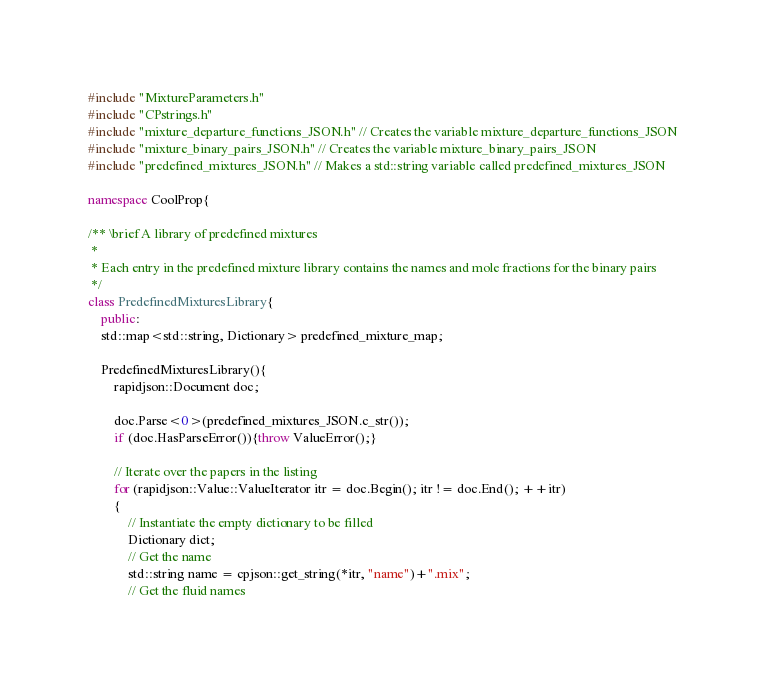<code> <loc_0><loc_0><loc_500><loc_500><_C++_>#include "MixtureParameters.h"
#include "CPstrings.h"
#include "mixture_departure_functions_JSON.h" // Creates the variable mixture_departure_functions_JSON
#include "mixture_binary_pairs_JSON.h" // Creates the variable mixture_binary_pairs_JSON
#include "predefined_mixtures_JSON.h" // Makes a std::string variable called predefined_mixtures_JSON

namespace CoolProp{

/** \brief A library of predefined mixtures
 *
 * Each entry in the predefined mixture library contains the names and mole fractions for the binary pairs
 */
class PredefinedMixturesLibrary{
    public:
    std::map<std::string, Dictionary> predefined_mixture_map;

    PredefinedMixturesLibrary(){
        rapidjson::Document doc;

        doc.Parse<0>(predefined_mixtures_JSON.c_str());
        if (doc.HasParseError()){throw ValueError();}

        // Iterate over the papers in the listing
        for (rapidjson::Value::ValueIterator itr = doc.Begin(); itr != doc.End(); ++itr)
        {
            // Instantiate the empty dictionary to be filled
            Dictionary dict;
            // Get the name
            std::string name = cpjson::get_string(*itr, "name")+".mix";
            // Get the fluid names</code> 